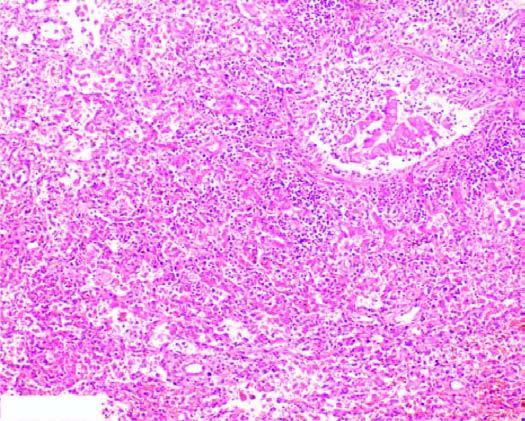re sectioned slice of the liver thickened due to congested capillaries and neutrophilic infiltrate?
Answer the question using a single word or phrase. No 